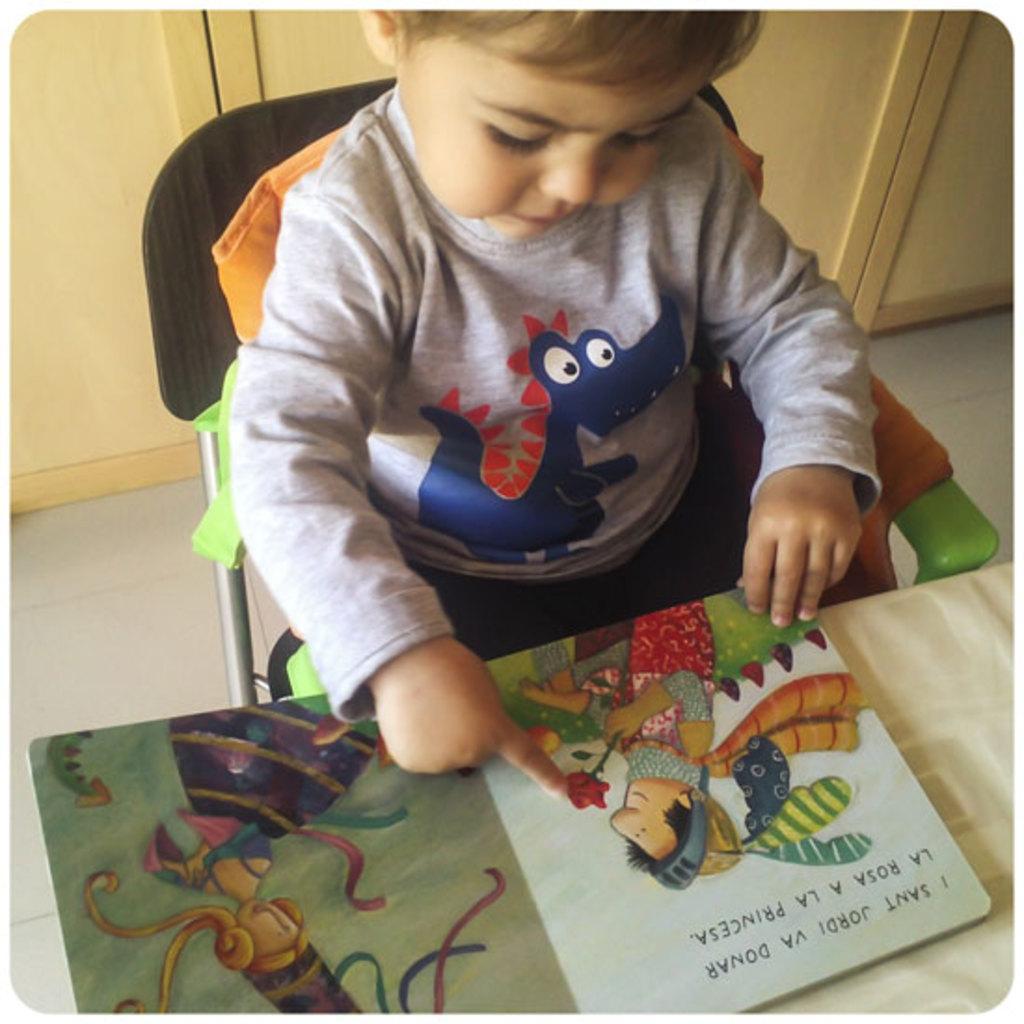Please provide a concise description of this image. In this picture there is a kid sitting in the chair and there is a book in front of him which has few paintings on it is placed on a table and there are few cupboards behind him. 